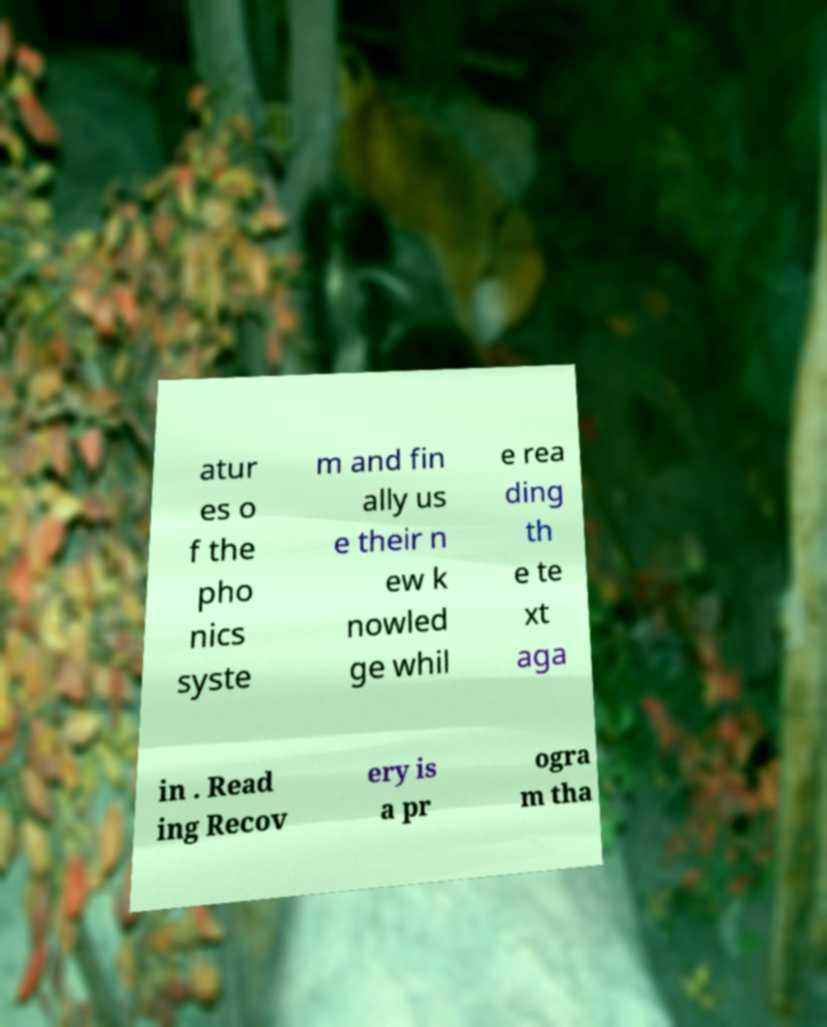Could you assist in decoding the text presented in this image and type it out clearly? atur es o f the pho nics syste m and fin ally us e their n ew k nowled ge whil e rea ding th e te xt aga in . Read ing Recov ery is a pr ogra m tha 